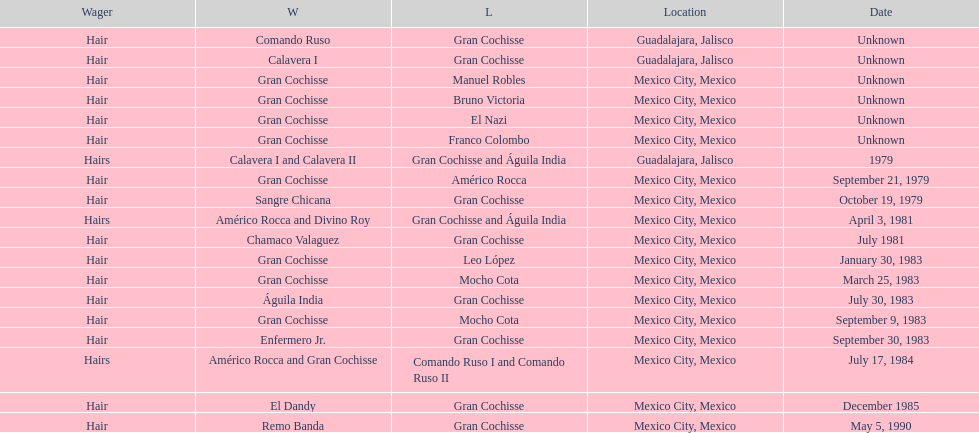What was the number of losses gran cochisse had against el dandy? 1. 